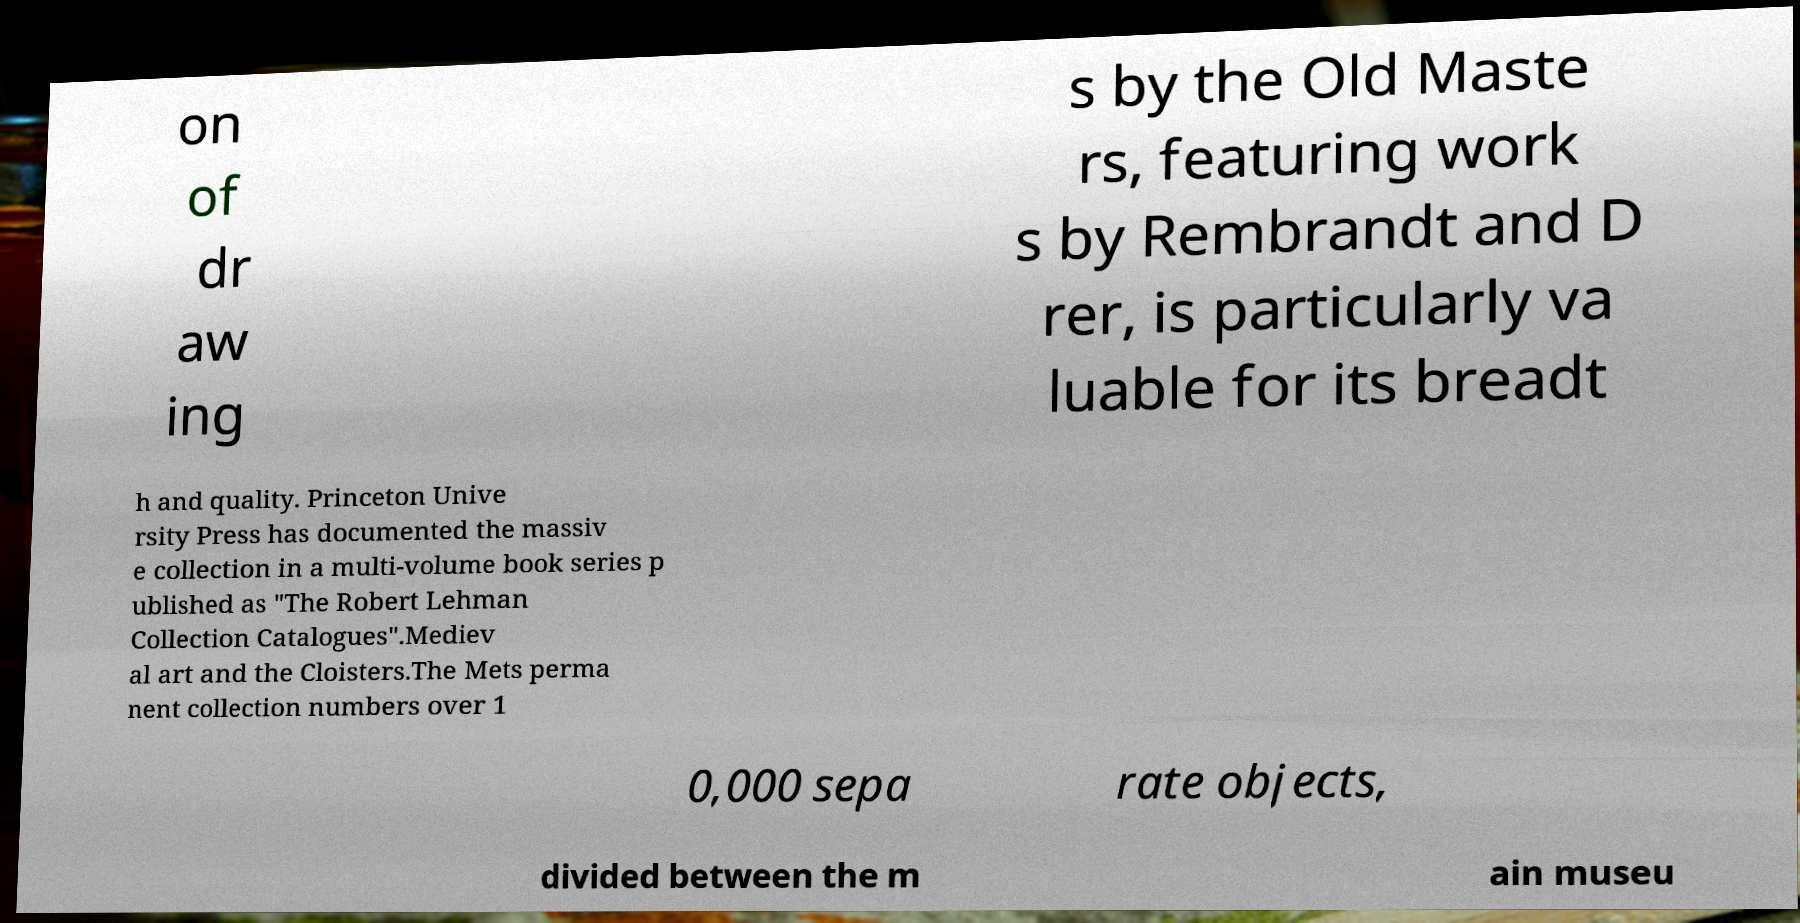Can you accurately transcribe the text from the provided image for me? on of dr aw ing s by the Old Maste rs, featuring work s by Rembrandt and D rer, is particularly va luable for its breadt h and quality. Princeton Unive rsity Press has documented the massiv e collection in a multi-volume book series p ublished as "The Robert Lehman Collection Catalogues".Mediev al art and the Cloisters.The Mets perma nent collection numbers over 1 0,000 sepa rate objects, divided between the m ain museu 